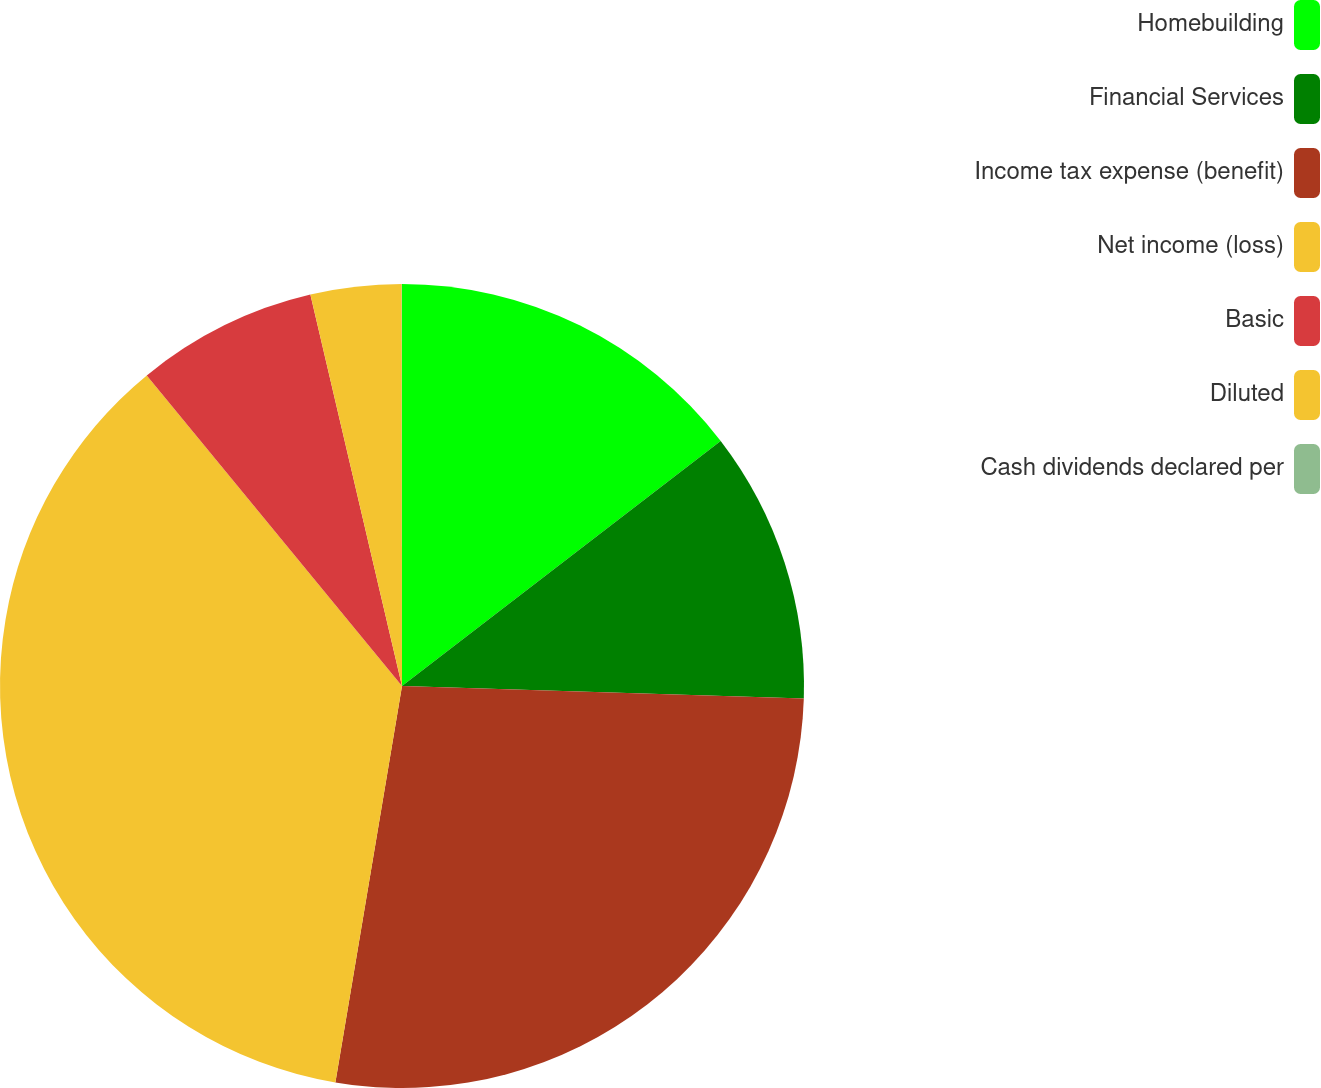<chart> <loc_0><loc_0><loc_500><loc_500><pie_chart><fcel>Homebuilding<fcel>Financial Services<fcel>Income tax expense (benefit)<fcel>Net income (loss)<fcel>Basic<fcel>Diluted<fcel>Cash dividends declared per<nl><fcel>14.57%<fcel>10.93%<fcel>27.16%<fcel>36.41%<fcel>7.29%<fcel>3.65%<fcel>0.01%<nl></chart> 